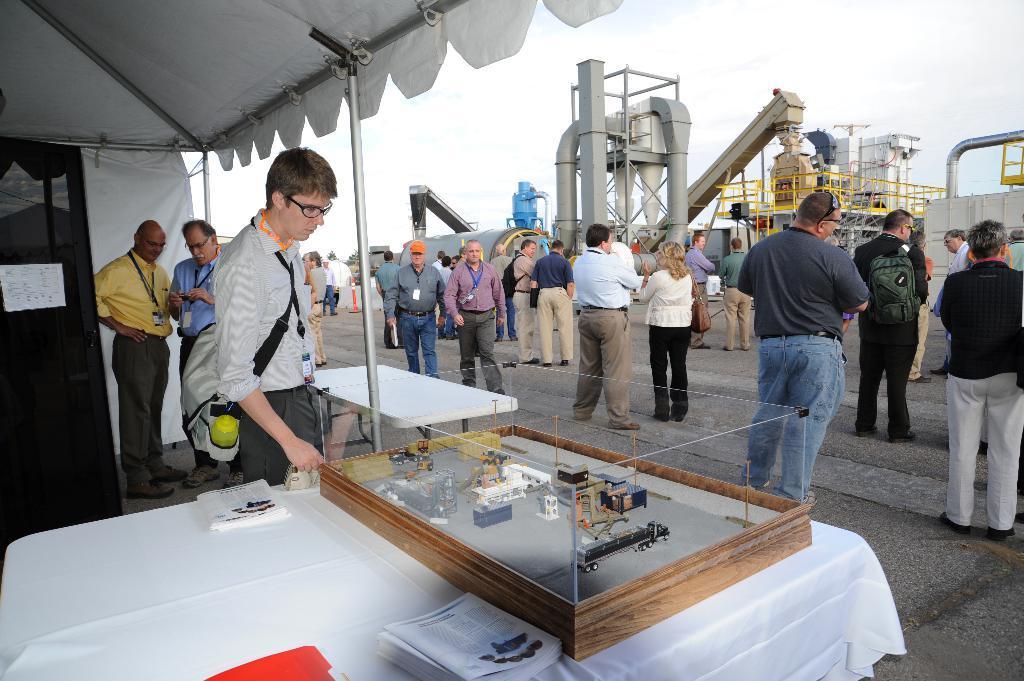Describe this image in one or two sentences. There are group of people in the in the picture and some machines. Here the people are wearing the id cards and some are wearing the back packs and there are two benches on which the things are been placed like papers and there is a tent above the benches. 